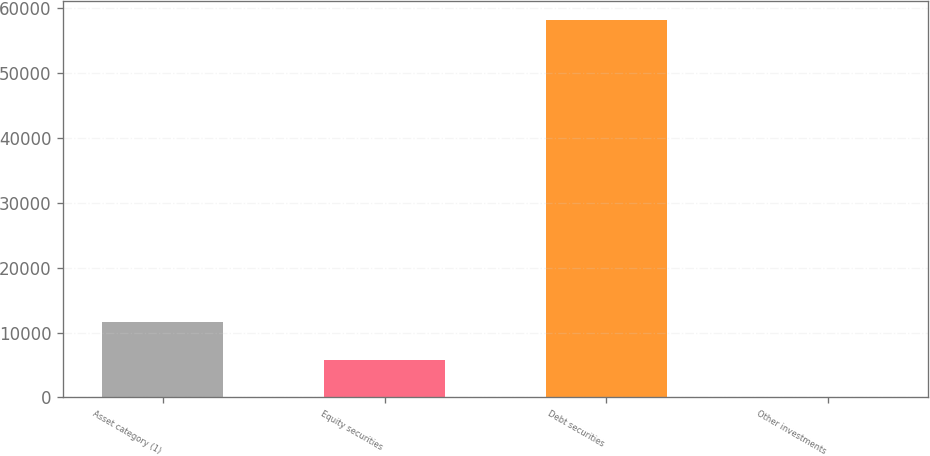Convert chart. <chart><loc_0><loc_0><loc_500><loc_500><bar_chart><fcel>Asset category (1)<fcel>Equity securities<fcel>Debt securities<fcel>Other investments<nl><fcel>11623.2<fcel>5813.6<fcel>58100<fcel>4<nl></chart> 